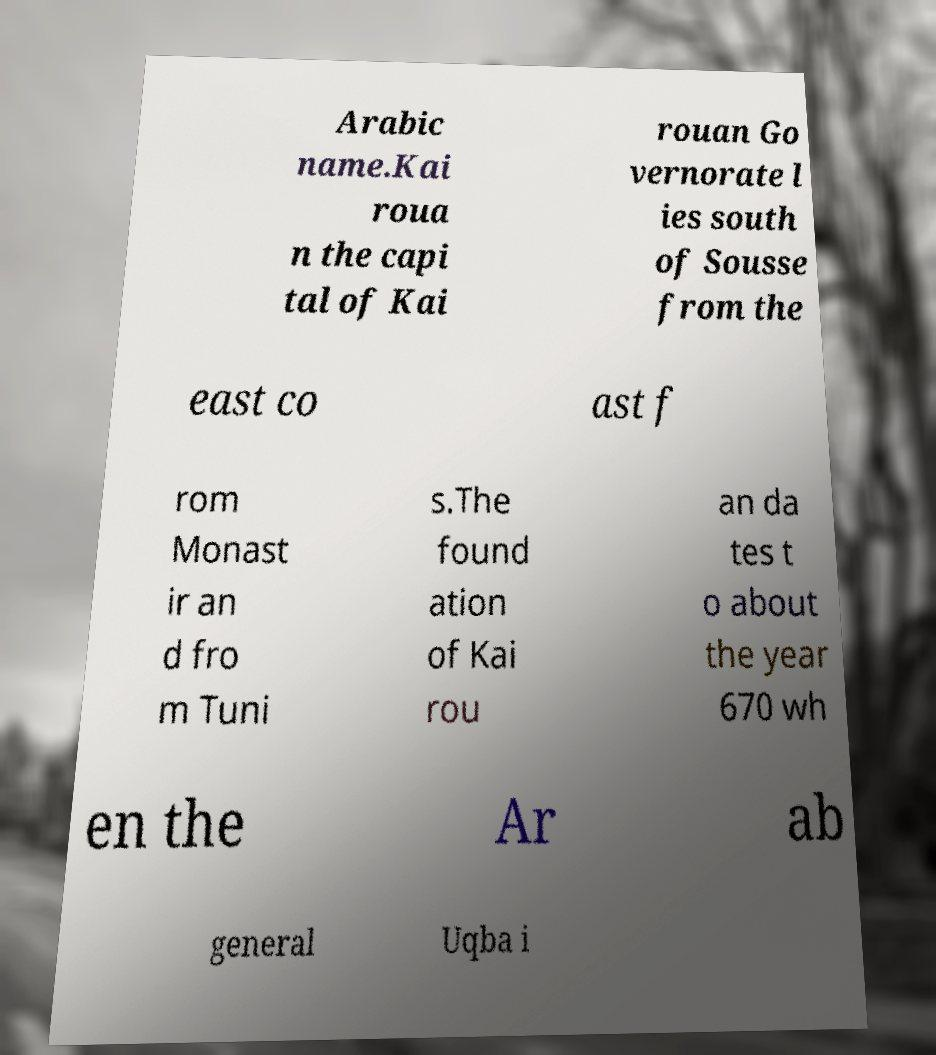Please read and relay the text visible in this image. What does it say? Arabic name.Kai roua n the capi tal of Kai rouan Go vernorate l ies south of Sousse from the east co ast f rom Monast ir an d fro m Tuni s.The found ation of Kai rou an da tes t o about the year 670 wh en the Ar ab general Uqba i 